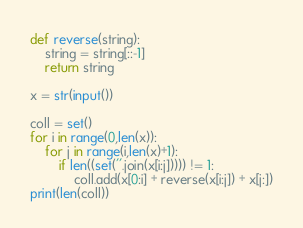Convert code to text. <code><loc_0><loc_0><loc_500><loc_500><_Python_>def reverse(string): 
    string = string[::-1] 
    return string

x = str(input())

coll = set()
for i in range(0,len(x)):
    for j in range(i,len(x)+1):
        if len((set(''.join(x[i:j])))) != 1:
            coll.add(x[0:i] + reverse(x[i:j]) + x[j:])
print(len(coll))</code> 